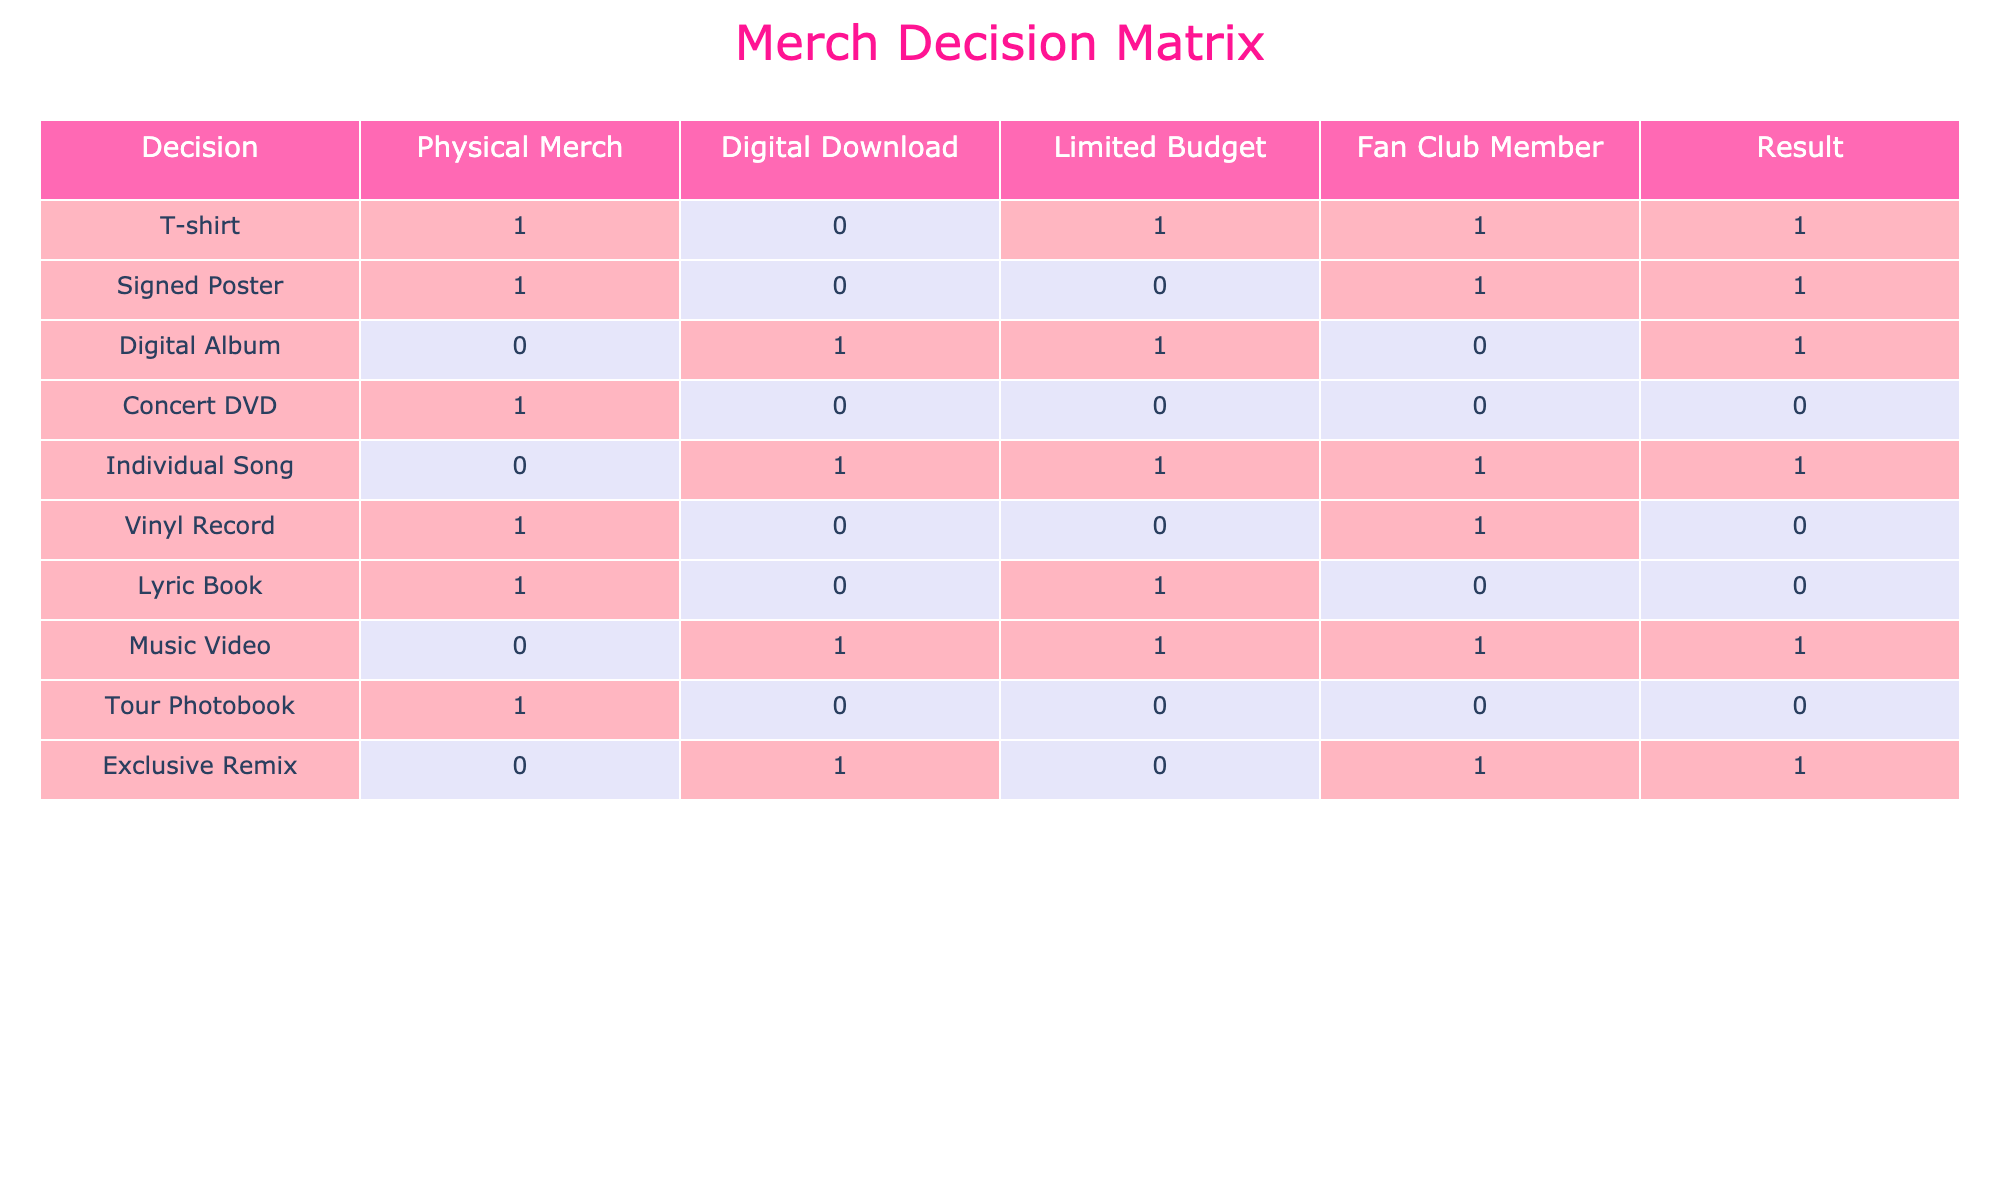What is the result for purchasing a T-shirt as a fan club member with a limited budget? The table shows that if someone purchases a T-shirt (1) while being a fan club member (1) and has a limited budget (1), the result indicated is 1 (true) for that combination.
Answer: Yes How many items have a result of 1 (true) for the Digital Download category? In the Digital Download column, the items with a result of 1 are: Digital Album, Individual Song, Music Video, and Exclusive Remix. Counting these gives us a total of 4 items.
Answer: 4 Is the Signed Poster a viable purchase if the individual does not have a limited budget but is a fan club member? The table indicates that when the criteria are: Signed Poster (1), no limited budget (0), and fan club member (1), the result is still true (1). Hence, it is a viable purchase.
Answer: Yes Which items have a result of 0 (false) when the purchaser is a fan club member and has a limited budget? Filtering the table for items where the fan club member status is 1 and limited budget is 1, we check the results: Signed Poster (1), Concert DVD (0), Vinyl Record (0), and Lyric Book (0). Only the Concert DVD item shows a result of 0 (false), meaning it is not a viable purchase in this scenario.
Answer: Concert DVD What’s the total number of items that can be purchased as digital downloads with a result of 1? Counting the items from the Digital Download column that have a result of 1 provides: Digital Album, Individual Song, Music Video, and Exclusive Remix. This totals to 4 items.
Answer: 4 If a person has a limited budget and wants to purchase physical merchandise, how many products are available to them? The physical merchandise items with a result of 1 under the limited budget condition are T-shirt (1), Signed Poster (1), and Tour Photobook (0). Thus, only the T-shirt and Signed Poster are available, giving a total of 2 items.
Answer: 2 Are there any digital downloads available that have a result of 1 despite having a limited budget? Checking the Digital Download column, we see that both the Digital Album and Individual Song have a result of 1 and can be classified under a limited budget constraint. Therefore, there are indeed digital downloads available under these criteria.
Answer: Yes What is the total number of items that have a result of 1 when purchased as physical merchandise? The items in the Physical Merch category with a result of 1 are: T-shirt, Signed Poster, and Concert DVD. Counting these gives us a total of 3 items.
Answer: 3 What is the result for purchasing a Vinyl Record with a limited budget and being a fan club member? In the Vinyl Record row, if we apply the conditions of a limited budget (0) and being a fan club member (1), we find that the result is 0 (false), meaning this is not a viable purchase option.
Answer: No 